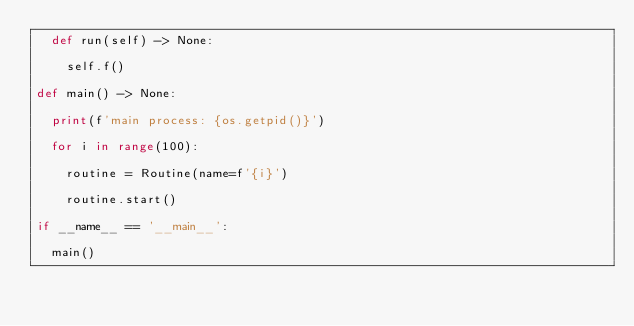<code> <loc_0><loc_0><loc_500><loc_500><_Python_>	def run(self) -> None:

		self.f()

def main() -> None:

	print(f'main process: {os.getpid()}')

	for i in range(100):

		routine = Routine(name=f'{i}')

		routine.start()

if __name__ == '__main__':

	main()
</code> 